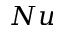<formula> <loc_0><loc_0><loc_500><loc_500>N u</formula> 